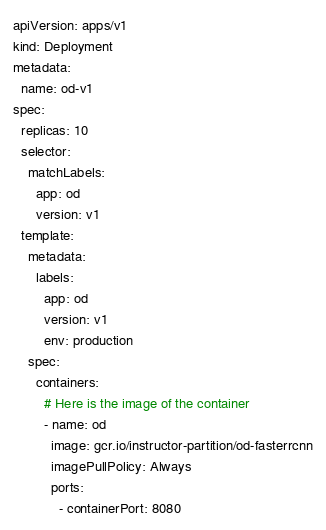<code> <loc_0><loc_0><loc_500><loc_500><_YAML_>apiVersion: apps/v1
kind: Deployment
metadata:
  name: od-v1
spec:
  replicas: 10
  selector:
    matchLabels:
      app: od
      version: v1
  template:
    metadata:
      labels:
        app: od
        version: v1
        env: production
    spec:
      containers:
        # Here is the image of the container
        - name: od
          image: gcr.io/instructor-partition/od-fasterrcnn
          imagePullPolicy: Always
          ports:
            - containerPort: 8080
</code> 